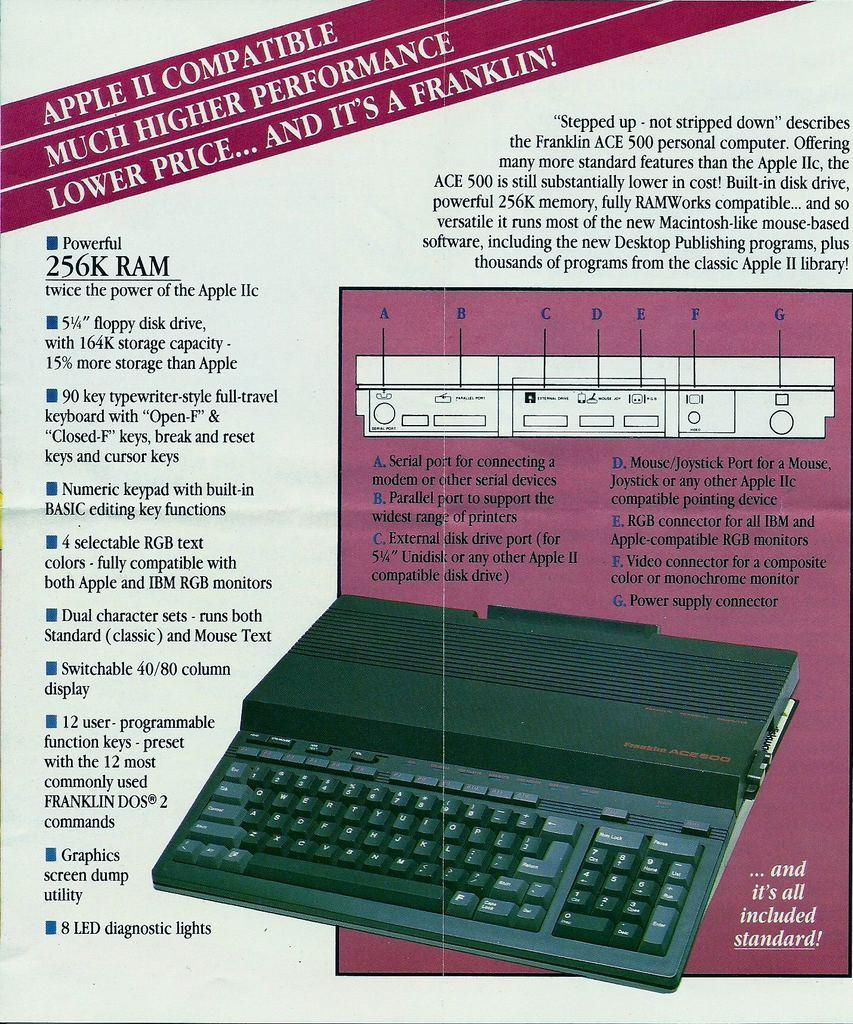<image>
Provide a brief description of the given image. the name Franklin is on the purple part of the paper 